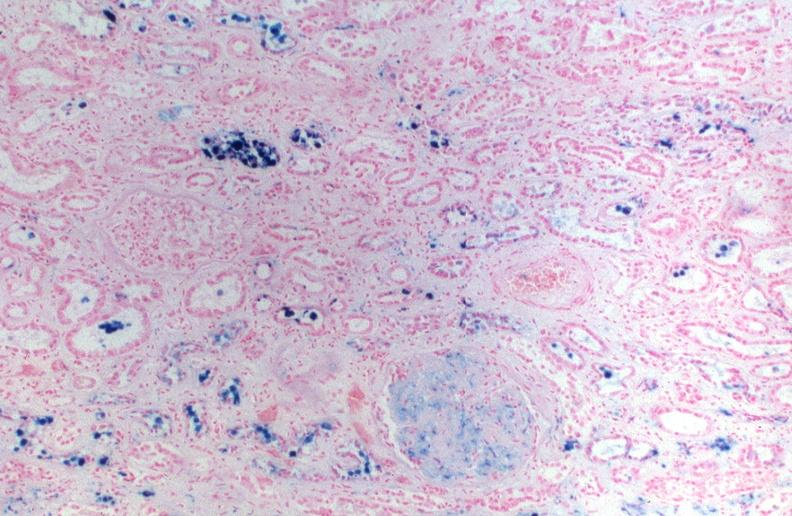does normal show kidney, hemochromatosis, prussian blue?
Answer the question using a single word or phrase. No 